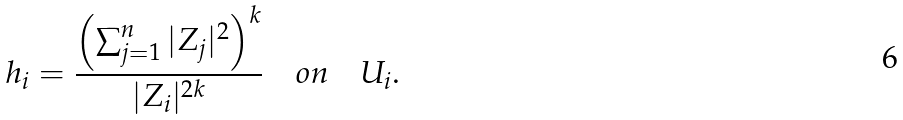Convert formula to latex. <formula><loc_0><loc_0><loc_500><loc_500>h _ { i } = \frac { \left ( \sum _ { j = 1 } ^ { n } | Z _ { j } | ^ { 2 } \right ) ^ { k } } { | Z _ { i } | ^ { 2 k } } \quad o n \quad U _ { i } .</formula> 